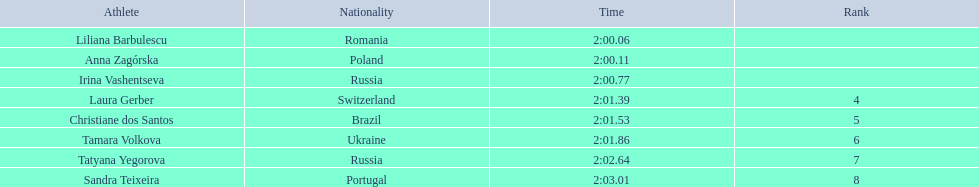What athletes are in the top five for the women's 800 metres? Liliana Barbulescu, Anna Zagórska, Irina Vashentseva, Laura Gerber, Christiane dos Santos. Which athletes are in the top 3? Liliana Barbulescu, Anna Zagórska, Irina Vashentseva. Who is the second place runner in the women's 800 metres? Anna Zagórska. What is the second place runner's time? 2:00.11. 